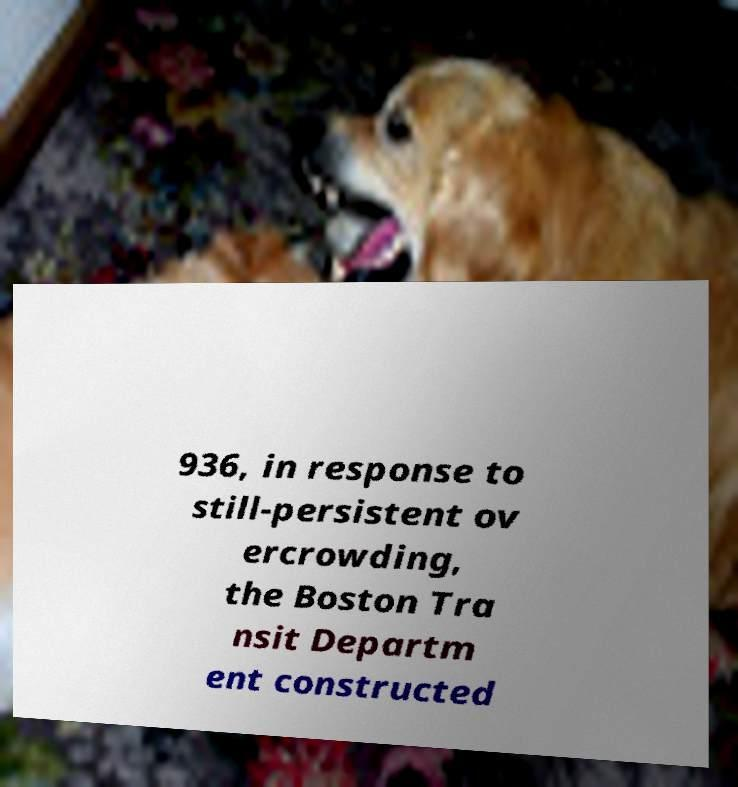What messages or text are displayed in this image? I need them in a readable, typed format. 936, in response to still-persistent ov ercrowding, the Boston Tra nsit Departm ent constructed 